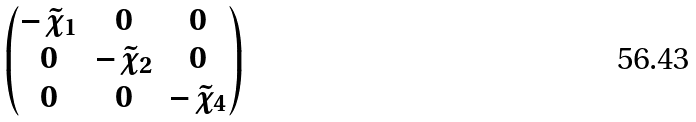<formula> <loc_0><loc_0><loc_500><loc_500>\begin{pmatrix} - \tilde { \chi } _ { 1 } & 0 & 0 \\ 0 & - \tilde { \chi } _ { 2 } & 0 \\ 0 & 0 & - \tilde { \chi } _ { 4 } \end{pmatrix}</formula> 